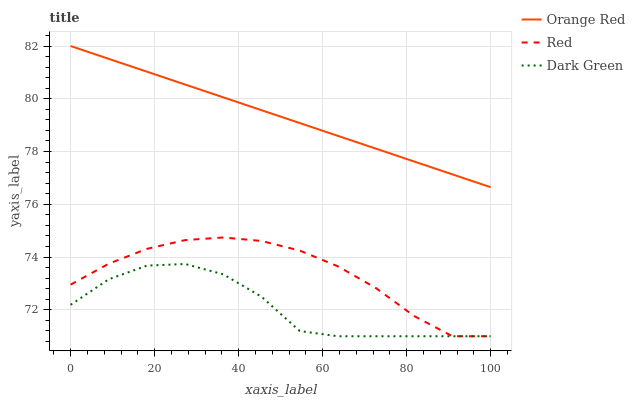Does Dark Green have the minimum area under the curve?
Answer yes or no. Yes. Does Orange Red have the maximum area under the curve?
Answer yes or no. Yes. Does Red have the minimum area under the curve?
Answer yes or no. No. Does Red have the maximum area under the curve?
Answer yes or no. No. Is Orange Red the smoothest?
Answer yes or no. Yes. Is Dark Green the roughest?
Answer yes or no. Yes. Is Red the smoothest?
Answer yes or no. No. Is Red the roughest?
Answer yes or no. No. Does Red have the lowest value?
Answer yes or no. Yes. Does Orange Red have the highest value?
Answer yes or no. Yes. Does Red have the highest value?
Answer yes or no. No. Is Dark Green less than Orange Red?
Answer yes or no. Yes. Is Orange Red greater than Red?
Answer yes or no. Yes. Does Red intersect Dark Green?
Answer yes or no. Yes. Is Red less than Dark Green?
Answer yes or no. No. Is Red greater than Dark Green?
Answer yes or no. No. Does Dark Green intersect Orange Red?
Answer yes or no. No. 